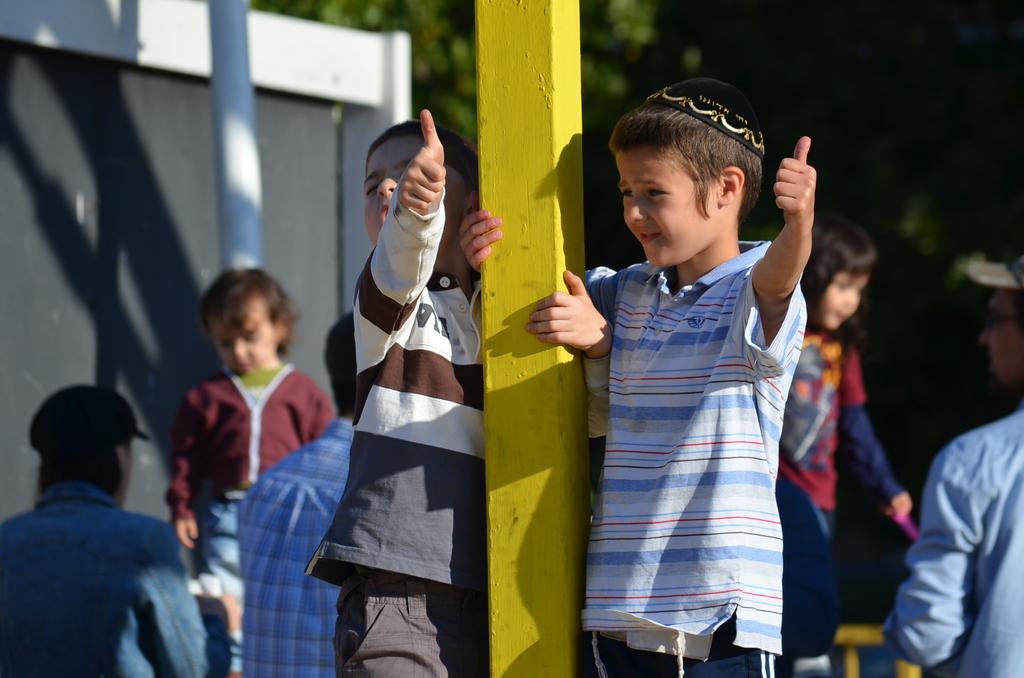In one or two sentences, can you explain what this image depicts? This image consists of many people. In the front, we can see two boys standing near the pillar. The pillar is made up of wood. It is in yellow color. In the background, we can see a wall along along with a pole. On the right, there are trees and the background is blurred. 